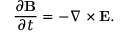<formula> <loc_0><loc_0><loc_500><loc_500>\frac { \partial { B } } { \partial t } = - \nabla \times { E } .</formula> 